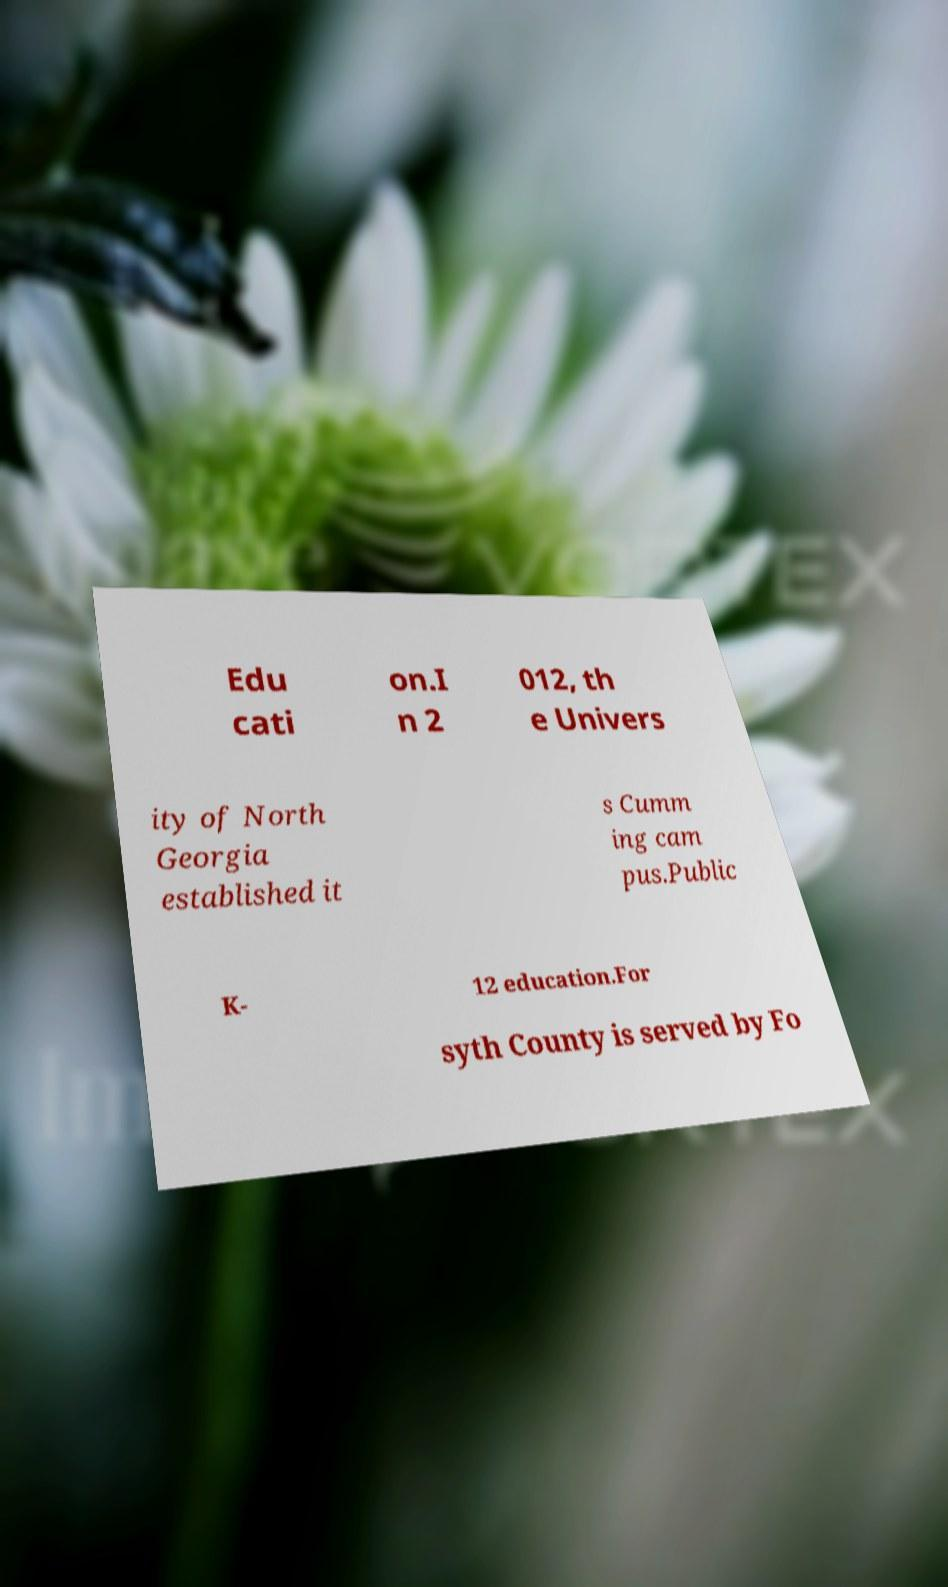Please read and relay the text visible in this image. What does it say? Edu cati on.I n 2 012, th e Univers ity of North Georgia established it s Cumm ing cam pus.Public K- 12 education.For syth County is served by Fo 